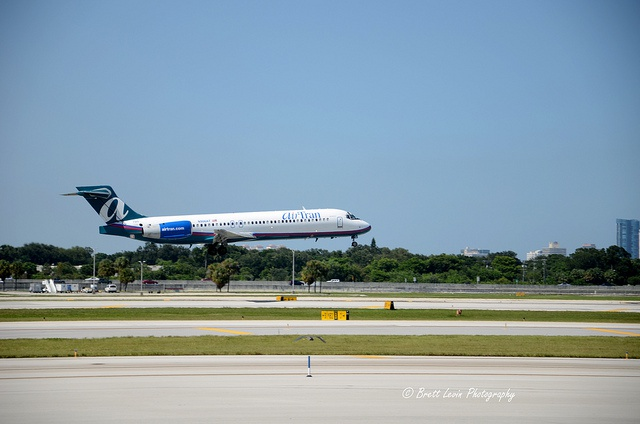Describe the objects in this image and their specific colors. I can see airplane in gray, white, darkgray, and black tones, truck in gray, darkgray, and black tones, car in gray, darkgray, black, and lightgray tones, truck in gray, darkgray, and lightgray tones, and car in gray, black, maroon, and purple tones in this image. 